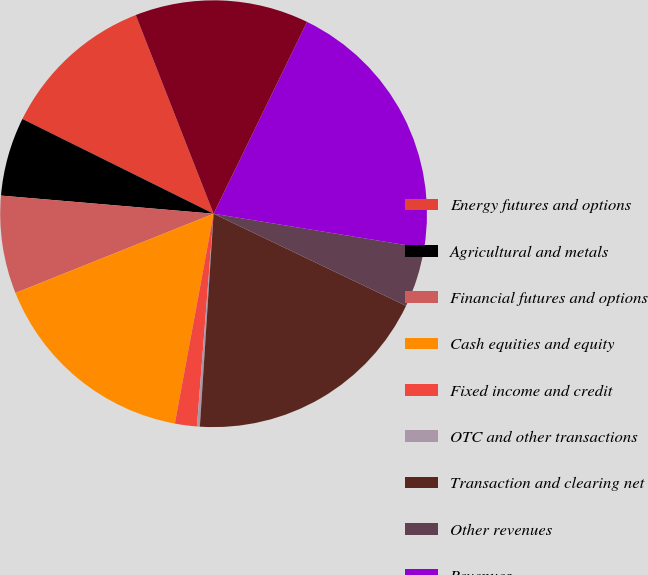<chart> <loc_0><loc_0><loc_500><loc_500><pie_chart><fcel>Energy futures and options<fcel>Agricultural and metals<fcel>Financial futures and options<fcel>Cash equities and equity<fcel>Fixed income and credit<fcel>OTC and other transactions<fcel>Transaction and clearing net<fcel>Other revenues<fcel>Revenues<fcel>Transaction-based expenses<nl><fcel>11.73%<fcel>5.97%<fcel>7.41%<fcel>16.04%<fcel>1.66%<fcel>0.22%<fcel>18.92%<fcel>4.53%<fcel>20.36%<fcel>13.16%<nl></chart> 